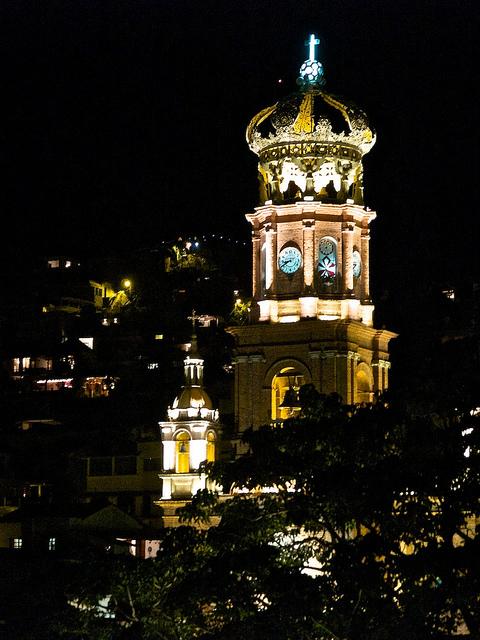Is it night time?
Concise answer only. Yes. What kind of tower is this?
Keep it brief. Church. Is that a clock?
Answer briefly. Yes. Where is the clock?
Write a very short answer. On tower. 